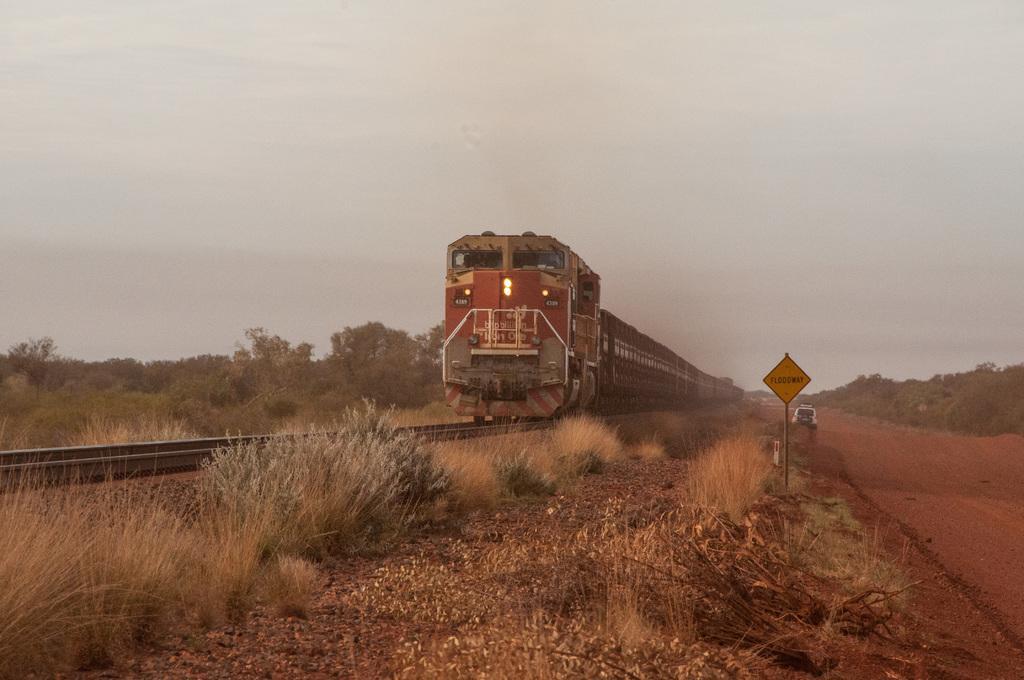Can you describe this image briefly? In the middle of the picture, we see a train in red color is moving on the railway tracks. Beside that, we see grass, shrubs and stones. Beside that, we see a yellow color board and a car is moving on the road. On the right side, there are trees. On the left side, we see trees. At the top of the picture, we see the sky. 